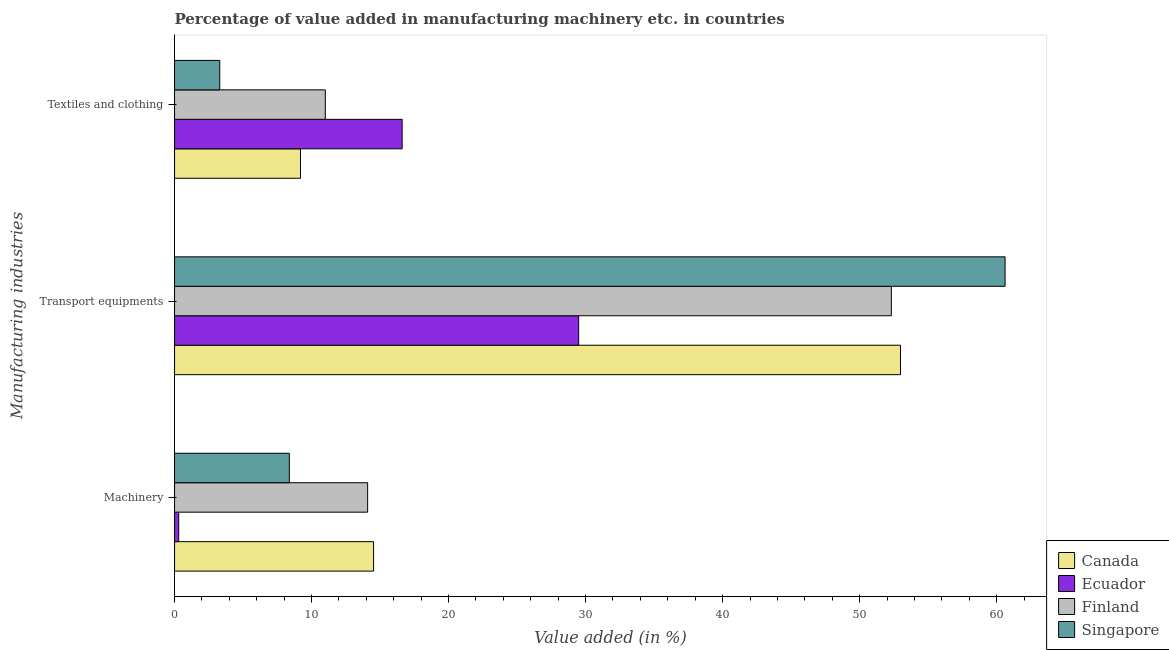How many groups of bars are there?
Provide a succinct answer. 3. Are the number of bars per tick equal to the number of legend labels?
Ensure brevity in your answer.  Yes. How many bars are there on the 3rd tick from the top?
Your response must be concise. 4. What is the label of the 2nd group of bars from the top?
Provide a short and direct response. Transport equipments. What is the value added in manufacturing textile and clothing in Canada?
Keep it short and to the point. 9.19. Across all countries, what is the maximum value added in manufacturing textile and clothing?
Keep it short and to the point. 16.61. Across all countries, what is the minimum value added in manufacturing machinery?
Provide a short and direct response. 0.3. In which country was the value added in manufacturing transport equipments maximum?
Your answer should be compact. Singapore. In which country was the value added in manufacturing textile and clothing minimum?
Your answer should be compact. Singapore. What is the total value added in manufacturing textile and clothing in the graph?
Give a very brief answer. 40.11. What is the difference between the value added in manufacturing machinery in Ecuador and that in Canada?
Ensure brevity in your answer.  -14.22. What is the difference between the value added in manufacturing textile and clothing in Singapore and the value added in manufacturing machinery in Canada?
Provide a succinct answer. -11.23. What is the average value added in manufacturing transport equipments per country?
Offer a terse response. 48.85. What is the difference between the value added in manufacturing machinery and value added in manufacturing transport equipments in Finland?
Your answer should be very brief. -38.22. What is the ratio of the value added in manufacturing machinery in Singapore to that in Finland?
Offer a terse response. 0.59. What is the difference between the highest and the second highest value added in manufacturing transport equipments?
Keep it short and to the point. 7.63. What is the difference between the highest and the lowest value added in manufacturing transport equipments?
Give a very brief answer. 31.12. In how many countries, is the value added in manufacturing transport equipments greater than the average value added in manufacturing transport equipments taken over all countries?
Your response must be concise. 3. What does the 4th bar from the top in Machinery represents?
Your answer should be compact. Canada. Is it the case that in every country, the sum of the value added in manufacturing machinery and value added in manufacturing transport equipments is greater than the value added in manufacturing textile and clothing?
Keep it short and to the point. Yes. How many bars are there?
Ensure brevity in your answer.  12. Are all the bars in the graph horizontal?
Your response must be concise. Yes. Are the values on the major ticks of X-axis written in scientific E-notation?
Your answer should be compact. No. Does the graph contain grids?
Ensure brevity in your answer.  No. How many legend labels are there?
Offer a very short reply. 4. How are the legend labels stacked?
Make the answer very short. Vertical. What is the title of the graph?
Provide a short and direct response. Percentage of value added in manufacturing machinery etc. in countries. What is the label or title of the X-axis?
Give a very brief answer. Value added (in %). What is the label or title of the Y-axis?
Your answer should be compact. Manufacturing industries. What is the Value added (in %) in Canada in Machinery?
Provide a short and direct response. 14.53. What is the Value added (in %) of Ecuador in Machinery?
Provide a short and direct response. 0.3. What is the Value added (in %) of Finland in Machinery?
Make the answer very short. 14.09. What is the Value added (in %) in Singapore in Machinery?
Ensure brevity in your answer.  8.38. What is the Value added (in %) in Canada in Transport equipments?
Keep it short and to the point. 52.98. What is the Value added (in %) of Ecuador in Transport equipments?
Provide a succinct answer. 29.49. What is the Value added (in %) in Finland in Transport equipments?
Provide a short and direct response. 52.32. What is the Value added (in %) of Singapore in Transport equipments?
Give a very brief answer. 60.62. What is the Value added (in %) in Canada in Textiles and clothing?
Provide a succinct answer. 9.19. What is the Value added (in %) in Ecuador in Textiles and clothing?
Your answer should be compact. 16.61. What is the Value added (in %) of Finland in Textiles and clothing?
Provide a succinct answer. 11. What is the Value added (in %) in Singapore in Textiles and clothing?
Make the answer very short. 3.3. Across all Manufacturing industries, what is the maximum Value added (in %) of Canada?
Your answer should be compact. 52.98. Across all Manufacturing industries, what is the maximum Value added (in %) of Ecuador?
Offer a terse response. 29.49. Across all Manufacturing industries, what is the maximum Value added (in %) of Finland?
Offer a very short reply. 52.32. Across all Manufacturing industries, what is the maximum Value added (in %) of Singapore?
Your answer should be very brief. 60.62. Across all Manufacturing industries, what is the minimum Value added (in %) in Canada?
Ensure brevity in your answer.  9.19. Across all Manufacturing industries, what is the minimum Value added (in %) in Ecuador?
Provide a succinct answer. 0.3. Across all Manufacturing industries, what is the minimum Value added (in %) of Finland?
Offer a terse response. 11. Across all Manufacturing industries, what is the minimum Value added (in %) in Singapore?
Give a very brief answer. 3.3. What is the total Value added (in %) in Canada in the graph?
Offer a terse response. 76.7. What is the total Value added (in %) of Ecuador in the graph?
Offer a very short reply. 46.41. What is the total Value added (in %) of Finland in the graph?
Your answer should be compact. 77.41. What is the total Value added (in %) of Singapore in the graph?
Provide a short and direct response. 72.29. What is the difference between the Value added (in %) of Canada in Machinery and that in Transport equipments?
Your response must be concise. -38.46. What is the difference between the Value added (in %) in Ecuador in Machinery and that in Transport equipments?
Make the answer very short. -29.19. What is the difference between the Value added (in %) in Finland in Machinery and that in Transport equipments?
Provide a succinct answer. -38.22. What is the difference between the Value added (in %) in Singapore in Machinery and that in Transport equipments?
Provide a succinct answer. -52.24. What is the difference between the Value added (in %) in Canada in Machinery and that in Textiles and clothing?
Ensure brevity in your answer.  5.33. What is the difference between the Value added (in %) in Ecuador in Machinery and that in Textiles and clothing?
Provide a succinct answer. -16.31. What is the difference between the Value added (in %) in Finland in Machinery and that in Textiles and clothing?
Provide a short and direct response. 3.09. What is the difference between the Value added (in %) of Singapore in Machinery and that in Textiles and clothing?
Your answer should be very brief. 5.08. What is the difference between the Value added (in %) of Canada in Transport equipments and that in Textiles and clothing?
Give a very brief answer. 43.79. What is the difference between the Value added (in %) in Ecuador in Transport equipments and that in Textiles and clothing?
Ensure brevity in your answer.  12.88. What is the difference between the Value added (in %) of Finland in Transport equipments and that in Textiles and clothing?
Offer a terse response. 41.31. What is the difference between the Value added (in %) of Singapore in Transport equipments and that in Textiles and clothing?
Offer a very short reply. 57.32. What is the difference between the Value added (in %) of Canada in Machinery and the Value added (in %) of Ecuador in Transport equipments?
Give a very brief answer. -14.97. What is the difference between the Value added (in %) of Canada in Machinery and the Value added (in %) of Finland in Transport equipments?
Your response must be concise. -37.79. What is the difference between the Value added (in %) in Canada in Machinery and the Value added (in %) in Singapore in Transport equipments?
Give a very brief answer. -46.09. What is the difference between the Value added (in %) of Ecuador in Machinery and the Value added (in %) of Finland in Transport equipments?
Ensure brevity in your answer.  -52.01. What is the difference between the Value added (in %) in Ecuador in Machinery and the Value added (in %) in Singapore in Transport equipments?
Offer a terse response. -60.31. What is the difference between the Value added (in %) of Finland in Machinery and the Value added (in %) of Singapore in Transport equipments?
Make the answer very short. -46.52. What is the difference between the Value added (in %) in Canada in Machinery and the Value added (in %) in Ecuador in Textiles and clothing?
Keep it short and to the point. -2.08. What is the difference between the Value added (in %) of Canada in Machinery and the Value added (in %) of Finland in Textiles and clothing?
Your response must be concise. 3.52. What is the difference between the Value added (in %) of Canada in Machinery and the Value added (in %) of Singapore in Textiles and clothing?
Provide a short and direct response. 11.23. What is the difference between the Value added (in %) of Ecuador in Machinery and the Value added (in %) of Finland in Textiles and clothing?
Your answer should be compact. -10.7. What is the difference between the Value added (in %) of Ecuador in Machinery and the Value added (in %) of Singapore in Textiles and clothing?
Your response must be concise. -2.99. What is the difference between the Value added (in %) in Finland in Machinery and the Value added (in %) in Singapore in Textiles and clothing?
Your answer should be very brief. 10.79. What is the difference between the Value added (in %) in Canada in Transport equipments and the Value added (in %) in Ecuador in Textiles and clothing?
Provide a short and direct response. 36.37. What is the difference between the Value added (in %) of Canada in Transport equipments and the Value added (in %) of Finland in Textiles and clothing?
Keep it short and to the point. 41.98. What is the difference between the Value added (in %) in Canada in Transport equipments and the Value added (in %) in Singapore in Textiles and clothing?
Your response must be concise. 49.68. What is the difference between the Value added (in %) of Ecuador in Transport equipments and the Value added (in %) of Finland in Textiles and clothing?
Provide a succinct answer. 18.49. What is the difference between the Value added (in %) of Ecuador in Transport equipments and the Value added (in %) of Singapore in Textiles and clothing?
Provide a succinct answer. 26.2. What is the difference between the Value added (in %) of Finland in Transport equipments and the Value added (in %) of Singapore in Textiles and clothing?
Ensure brevity in your answer.  49.02. What is the average Value added (in %) of Canada per Manufacturing industries?
Your response must be concise. 25.57. What is the average Value added (in %) in Ecuador per Manufacturing industries?
Offer a very short reply. 15.47. What is the average Value added (in %) of Finland per Manufacturing industries?
Make the answer very short. 25.8. What is the average Value added (in %) of Singapore per Manufacturing industries?
Give a very brief answer. 24.1. What is the difference between the Value added (in %) in Canada and Value added (in %) in Ecuador in Machinery?
Provide a succinct answer. 14.22. What is the difference between the Value added (in %) of Canada and Value added (in %) of Finland in Machinery?
Offer a terse response. 0.43. What is the difference between the Value added (in %) of Canada and Value added (in %) of Singapore in Machinery?
Make the answer very short. 6.15. What is the difference between the Value added (in %) of Ecuador and Value added (in %) of Finland in Machinery?
Offer a terse response. -13.79. What is the difference between the Value added (in %) in Ecuador and Value added (in %) in Singapore in Machinery?
Your response must be concise. -8.07. What is the difference between the Value added (in %) of Finland and Value added (in %) of Singapore in Machinery?
Ensure brevity in your answer.  5.71. What is the difference between the Value added (in %) of Canada and Value added (in %) of Ecuador in Transport equipments?
Make the answer very short. 23.49. What is the difference between the Value added (in %) in Canada and Value added (in %) in Finland in Transport equipments?
Offer a very short reply. 0.67. What is the difference between the Value added (in %) in Canada and Value added (in %) in Singapore in Transport equipments?
Offer a very short reply. -7.63. What is the difference between the Value added (in %) in Ecuador and Value added (in %) in Finland in Transport equipments?
Give a very brief answer. -22.82. What is the difference between the Value added (in %) in Ecuador and Value added (in %) in Singapore in Transport equipments?
Ensure brevity in your answer.  -31.12. What is the difference between the Value added (in %) in Finland and Value added (in %) in Singapore in Transport equipments?
Your response must be concise. -8.3. What is the difference between the Value added (in %) in Canada and Value added (in %) in Ecuador in Textiles and clothing?
Make the answer very short. -7.42. What is the difference between the Value added (in %) in Canada and Value added (in %) in Finland in Textiles and clothing?
Keep it short and to the point. -1.81. What is the difference between the Value added (in %) in Canada and Value added (in %) in Singapore in Textiles and clothing?
Ensure brevity in your answer.  5.9. What is the difference between the Value added (in %) of Ecuador and Value added (in %) of Finland in Textiles and clothing?
Your answer should be very brief. 5.61. What is the difference between the Value added (in %) in Ecuador and Value added (in %) in Singapore in Textiles and clothing?
Provide a succinct answer. 13.31. What is the difference between the Value added (in %) in Finland and Value added (in %) in Singapore in Textiles and clothing?
Your response must be concise. 7.71. What is the ratio of the Value added (in %) in Canada in Machinery to that in Transport equipments?
Give a very brief answer. 0.27. What is the ratio of the Value added (in %) in Ecuador in Machinery to that in Transport equipments?
Give a very brief answer. 0.01. What is the ratio of the Value added (in %) of Finland in Machinery to that in Transport equipments?
Provide a short and direct response. 0.27. What is the ratio of the Value added (in %) in Singapore in Machinery to that in Transport equipments?
Provide a short and direct response. 0.14. What is the ratio of the Value added (in %) in Canada in Machinery to that in Textiles and clothing?
Make the answer very short. 1.58. What is the ratio of the Value added (in %) in Ecuador in Machinery to that in Textiles and clothing?
Provide a succinct answer. 0.02. What is the ratio of the Value added (in %) of Finland in Machinery to that in Textiles and clothing?
Your response must be concise. 1.28. What is the ratio of the Value added (in %) of Singapore in Machinery to that in Textiles and clothing?
Provide a short and direct response. 2.54. What is the ratio of the Value added (in %) in Canada in Transport equipments to that in Textiles and clothing?
Ensure brevity in your answer.  5.76. What is the ratio of the Value added (in %) of Ecuador in Transport equipments to that in Textiles and clothing?
Your answer should be very brief. 1.78. What is the ratio of the Value added (in %) of Finland in Transport equipments to that in Textiles and clothing?
Ensure brevity in your answer.  4.75. What is the ratio of the Value added (in %) of Singapore in Transport equipments to that in Textiles and clothing?
Keep it short and to the point. 18.38. What is the difference between the highest and the second highest Value added (in %) of Canada?
Your answer should be very brief. 38.46. What is the difference between the highest and the second highest Value added (in %) of Ecuador?
Ensure brevity in your answer.  12.88. What is the difference between the highest and the second highest Value added (in %) in Finland?
Give a very brief answer. 38.22. What is the difference between the highest and the second highest Value added (in %) in Singapore?
Your response must be concise. 52.24. What is the difference between the highest and the lowest Value added (in %) in Canada?
Your answer should be very brief. 43.79. What is the difference between the highest and the lowest Value added (in %) in Ecuador?
Provide a short and direct response. 29.19. What is the difference between the highest and the lowest Value added (in %) of Finland?
Give a very brief answer. 41.31. What is the difference between the highest and the lowest Value added (in %) of Singapore?
Provide a succinct answer. 57.32. 